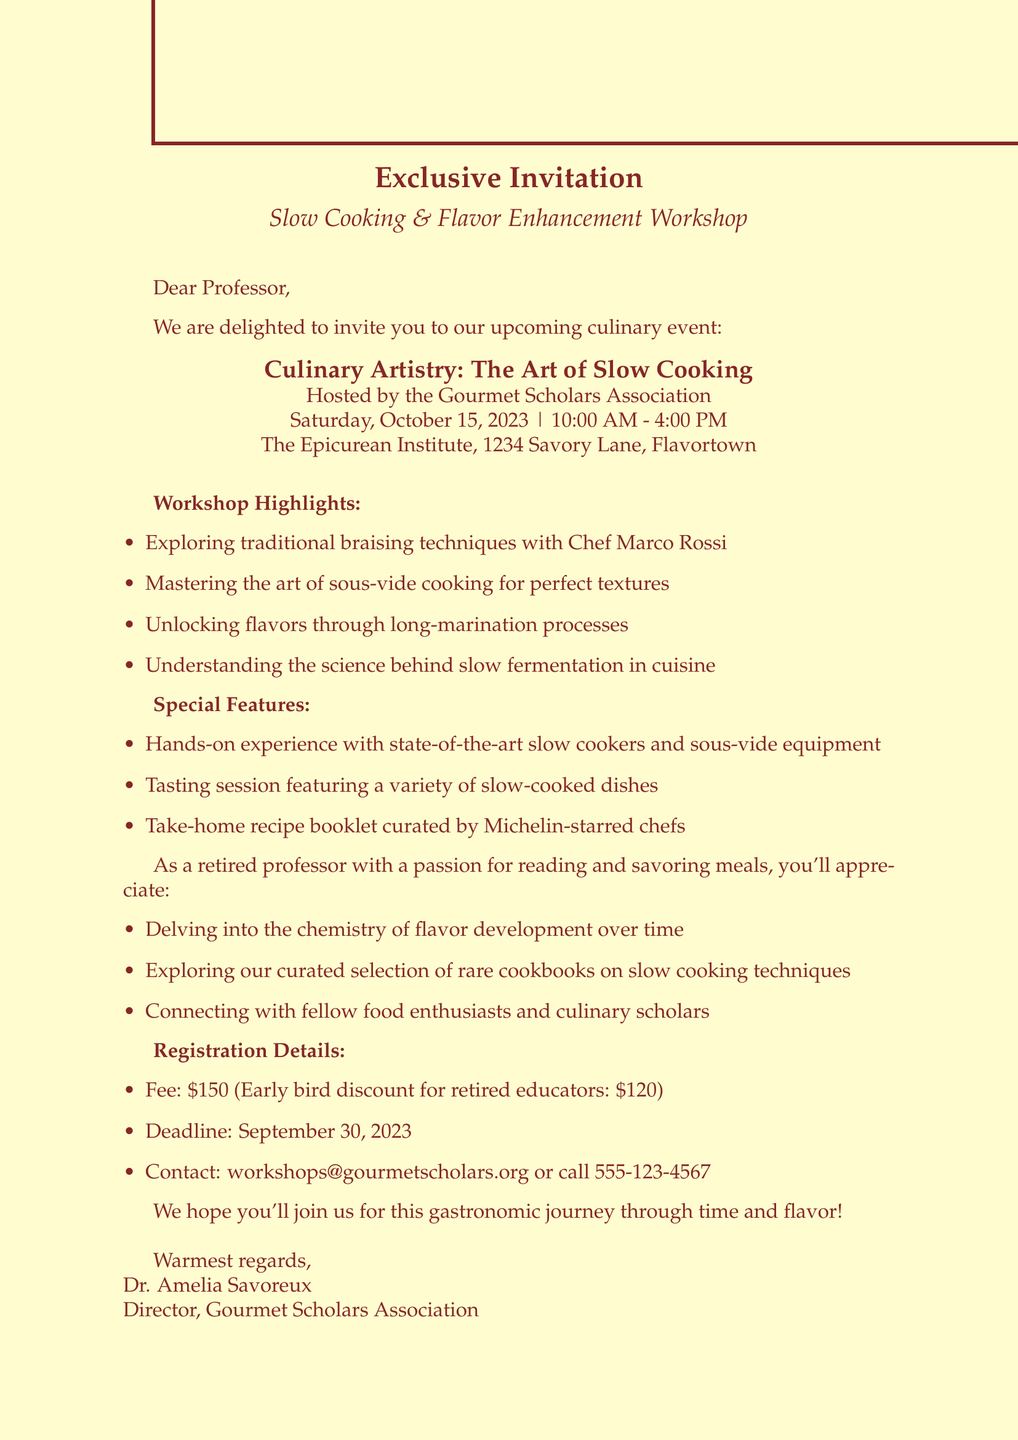What is the event name? The event name is explicitly stated in the introduction of the document as "Culinary Artistry: The Art of Slow Cooking."
Answer: Culinary Artistry: The Art of Slow Cooking Who is organizing the workshop? The organizer of the workshop is mentioned in the introduction section as the "Gourmet Scholars Association."
Answer: Gourmet Scholars Association What is the early bird fee for retired educators? The early bird discount for retired educators is specified in the registration details as "$120."
Answer: $120 What is the deadline for registration? The deadline for registration is clearly noted in the document as "September 30, 2023."
Answer: September 30, 2023 Which cooking technique is highlighted by Chef Marco Rossi? The document mentions that Chef Marco Rossi will highlight "traditional braising techniques."
Answer: traditional braising techniques What special feature involves tasting? The special feature that includes tasting is a "Tasting session featuring a variety of slow-cooked dishes."
Answer: Tasting session featuring a variety of slow-cooked dishes What aspect of the workshop appeals to retired professors? The appeal to retired professors includes "Delving into the chemistry of flavor development over time."
Answer: Delving into the chemistry of flavor development over time What is the venue for the event? The venue for the event is stated as "The Epicurean Institute, 1234 Savory Lane, Flavortown."
Answer: The Epicurean Institute, 1234 Savory Lane, Flavortown 